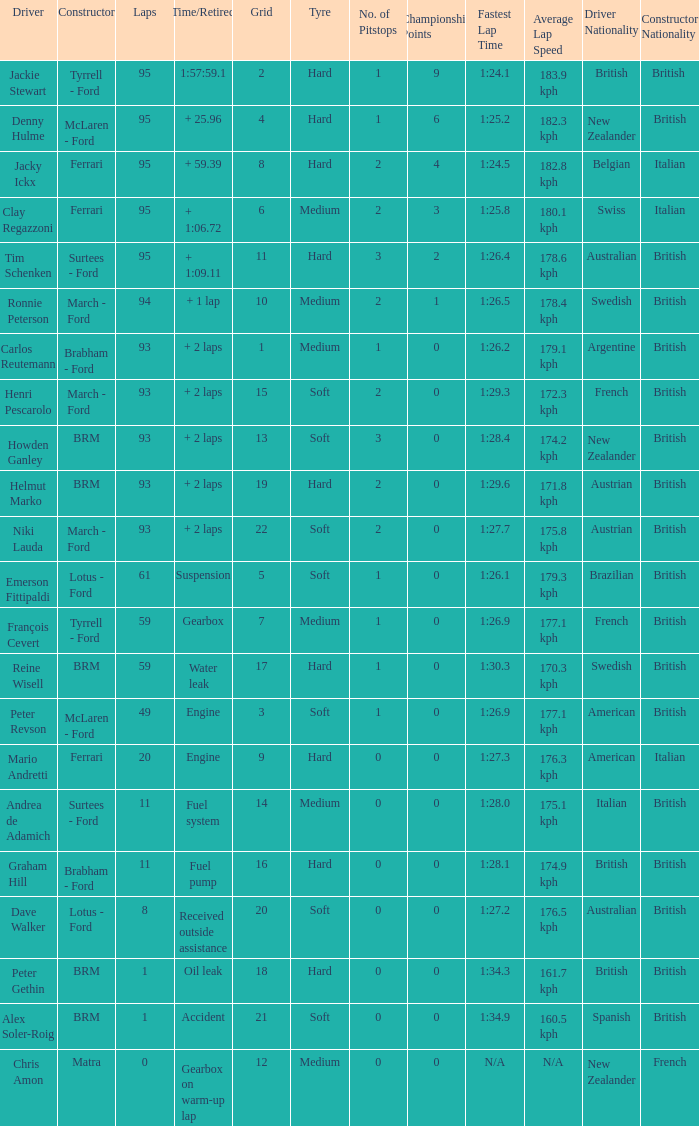Can you parse all the data within this table? {'header': ['Driver', 'Constructor', 'Laps', 'Time/Retired', 'Grid', 'Tyre', 'No. of Pitstops', 'Championship Points', 'Fastest Lap Time', 'Average Lap Speed', 'Driver Nationality', 'Constructor Nationality'], 'rows': [['Jackie Stewart', 'Tyrrell - Ford', '95', '1:57:59.1', '2', 'Hard', '1', '9', '1:24.1', '183.9 kph', 'British', 'British '], ['Denny Hulme', 'McLaren - Ford', '95', '+ 25.96', '4', 'Hard', '1', '6', '1:25.2', '182.3 kph', 'New Zealander', 'British'], ['Jacky Ickx', 'Ferrari', '95', '+ 59.39', '8', 'Hard', '2', '4', '1:24.5', '182.8 kph', 'Belgian', 'Italian'], ['Clay Regazzoni', 'Ferrari', '95', '+ 1:06.72', '6', 'Medium', '2', '3', '1:25.8', '180.1 kph', 'Swiss', 'Italian'], ['Tim Schenken', 'Surtees - Ford', '95', '+ 1:09.11', '11', 'Hard', '3', '2', '1:26.4', '178.6 kph', 'Australian', 'British'], ['Ronnie Peterson', 'March - Ford', '94', '+ 1 lap', '10', 'Medium', '2', '1', '1:26.5', '178.4 kph', 'Swedish', 'British'], ['Carlos Reutemann', 'Brabham - Ford', '93', '+ 2 laps', '1', 'Medium', '1', '0', '1:26.2', '179.1 kph', 'Argentine', 'British'], ['Henri Pescarolo', 'March - Ford', '93', '+ 2 laps', '15', 'Soft', '2', '0', '1:29.3', '172.3 kph', 'French', 'British'], ['Howden Ganley', 'BRM', '93', '+ 2 laps', '13', 'Soft', '3', '0', '1:28.4', '174.2 kph', 'New Zealander', 'British'], ['Helmut Marko', 'BRM', '93', '+ 2 laps', '19', 'Hard', '2', '0', '1:29.6', '171.8 kph', 'Austrian', 'British'], ['Niki Lauda', 'March - Ford', '93', '+ 2 laps', '22', 'Soft', '2', '0', '1:27.7', '175.8 kph', 'Austrian', 'British'], ['Emerson Fittipaldi', 'Lotus - Ford', '61', 'Suspension', '5', 'Soft', '1', '0', '1:26.1', '179.3 kph', 'Brazilian', 'British'], ['François Cevert', 'Tyrrell - Ford', '59', 'Gearbox', '7', 'Medium', '1', '0', '1:26.9', '177.1 kph', 'French', 'British'], ['Reine Wisell', 'BRM', '59', 'Water leak', '17', 'Hard', '1', '0', '1:30.3', '170.3 kph', 'Swedish', 'British'], ['Peter Revson', 'McLaren - Ford', '49', 'Engine', '3', 'Soft', '1', '0', '1:26.9', '177.1 kph', 'American', 'British'], ['Mario Andretti', 'Ferrari', '20', 'Engine', '9', 'Hard', '0', '0', '1:27.3', '176.3 kph', 'American', 'Italian'], ['Andrea de Adamich', 'Surtees - Ford', '11', 'Fuel system', '14', 'Medium', '0', '0', '1:28.0', '175.1 kph', 'Italian', 'British'], ['Graham Hill', 'Brabham - Ford', '11', 'Fuel pump', '16', 'Hard', '0', '0', '1:28.1', '174.9 kph', 'British', 'British'], ['Dave Walker', 'Lotus - Ford', '8', 'Received outside assistance', '20', 'Soft', '0', '0', '1:27.2', '176.5 kph', 'Australian', 'British'], ['Peter Gethin', 'BRM', '1', 'Oil leak', '18', 'Hard', '0', '0', '1:34.3', '161.7 kph', 'British', 'British'], ['Alex Soler-Roig', 'BRM', '1', 'Accident', '21', 'Soft', '0', '0', '1:34.9', '160.5 kph', 'Spanish', 'British'], ['Chris Amon', 'Matra', '0', 'Gearbox on warm-up lap', '12', 'Medium', '0', '0', 'N/A', 'N/A', 'New Zealander', 'French']]} What is the total number of grids for peter gethin? 18.0. 